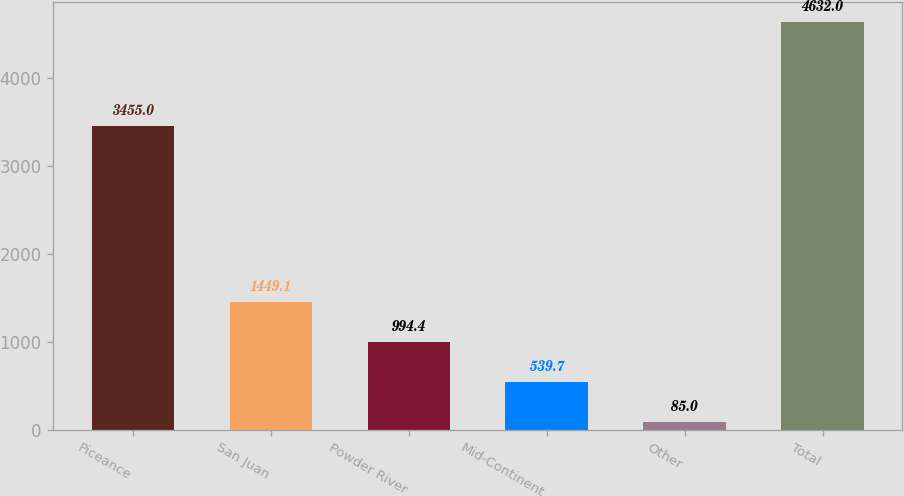<chart> <loc_0><loc_0><loc_500><loc_500><bar_chart><fcel>Piceance<fcel>San Juan<fcel>Powder River<fcel>Mid-Continent<fcel>Other<fcel>Total<nl><fcel>3455<fcel>1449.1<fcel>994.4<fcel>539.7<fcel>85<fcel>4632<nl></chart> 